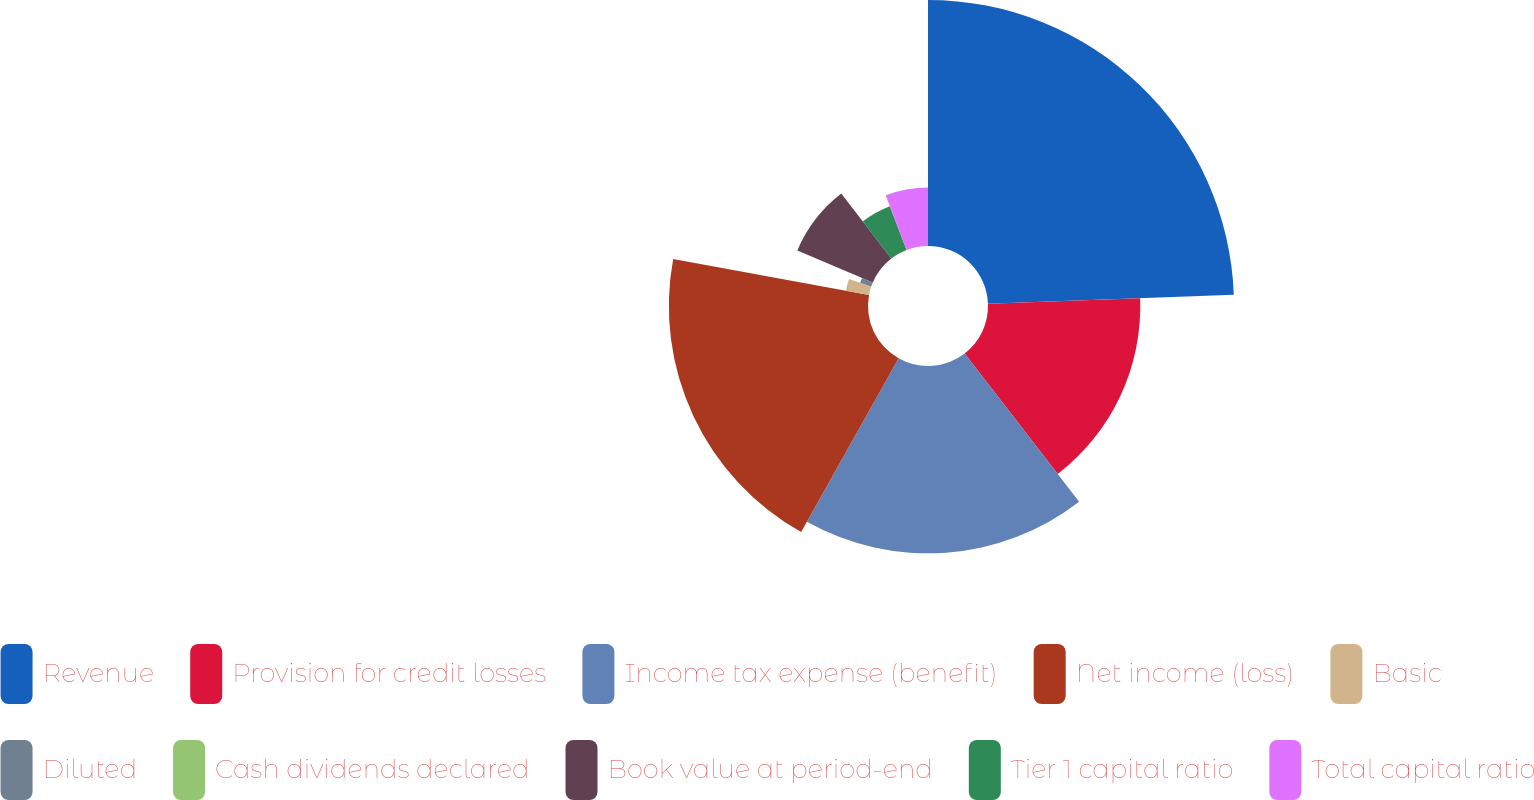<chart> <loc_0><loc_0><loc_500><loc_500><pie_chart><fcel>Revenue<fcel>Provision for credit losses<fcel>Income tax expense (benefit)<fcel>Net income (loss)<fcel>Basic<fcel>Diluted<fcel>Cash dividends declared<fcel>Book value at period-end<fcel>Tier 1 capital ratio<fcel>Total capital ratio<nl><fcel>24.42%<fcel>15.12%<fcel>18.6%<fcel>19.77%<fcel>2.33%<fcel>1.16%<fcel>0.0%<fcel>8.14%<fcel>4.65%<fcel>5.81%<nl></chart> 